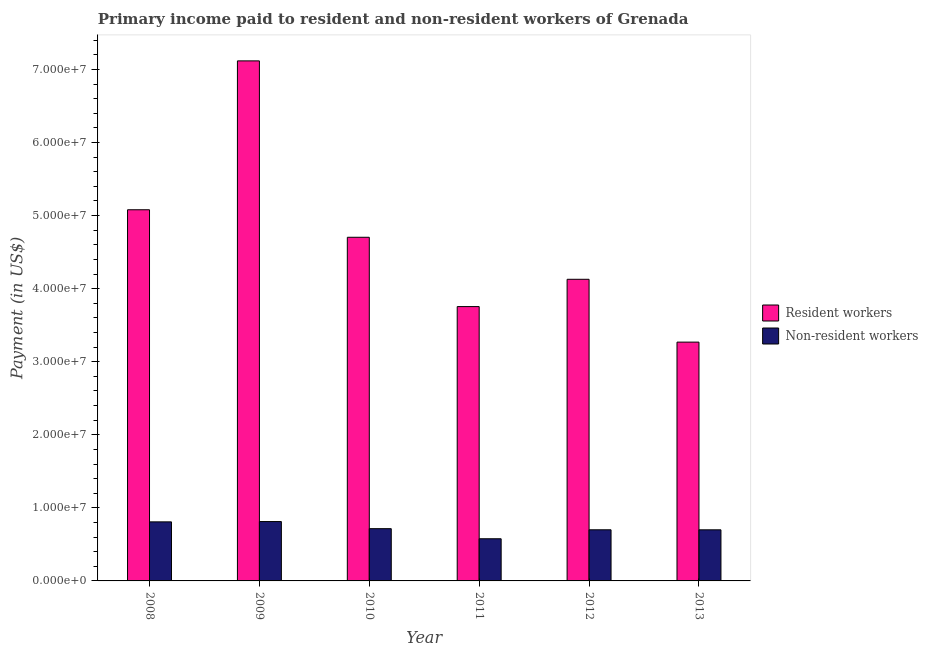Are the number of bars per tick equal to the number of legend labels?
Offer a very short reply. Yes. Are the number of bars on each tick of the X-axis equal?
Your answer should be very brief. Yes. How many bars are there on the 6th tick from the left?
Make the answer very short. 2. How many bars are there on the 1st tick from the right?
Your answer should be very brief. 2. What is the label of the 2nd group of bars from the left?
Ensure brevity in your answer.  2009. In how many cases, is the number of bars for a given year not equal to the number of legend labels?
Make the answer very short. 0. What is the payment made to non-resident workers in 2010?
Your answer should be very brief. 7.15e+06. Across all years, what is the maximum payment made to resident workers?
Give a very brief answer. 7.12e+07. Across all years, what is the minimum payment made to resident workers?
Your response must be concise. 3.27e+07. In which year was the payment made to non-resident workers maximum?
Provide a succinct answer. 2009. In which year was the payment made to resident workers minimum?
Provide a succinct answer. 2013. What is the total payment made to resident workers in the graph?
Offer a very short reply. 2.80e+08. What is the difference between the payment made to non-resident workers in 2012 and that in 2013?
Ensure brevity in your answer.  4373.7. What is the difference between the payment made to resident workers in 2012 and the payment made to non-resident workers in 2010?
Provide a short and direct response. -5.75e+06. What is the average payment made to resident workers per year?
Provide a succinct answer. 4.67e+07. In how many years, is the payment made to non-resident workers greater than 56000000 US$?
Offer a terse response. 0. What is the ratio of the payment made to resident workers in 2008 to that in 2010?
Your answer should be very brief. 1.08. Is the difference between the payment made to non-resident workers in 2011 and 2012 greater than the difference between the payment made to resident workers in 2011 and 2012?
Your response must be concise. No. What is the difference between the highest and the second highest payment made to resident workers?
Your answer should be very brief. 2.04e+07. What is the difference between the highest and the lowest payment made to resident workers?
Your answer should be very brief. 3.85e+07. In how many years, is the payment made to resident workers greater than the average payment made to resident workers taken over all years?
Offer a terse response. 3. What does the 1st bar from the left in 2009 represents?
Offer a terse response. Resident workers. What does the 2nd bar from the right in 2011 represents?
Offer a very short reply. Resident workers. How many years are there in the graph?
Make the answer very short. 6. Are the values on the major ticks of Y-axis written in scientific E-notation?
Keep it short and to the point. Yes. Does the graph contain grids?
Make the answer very short. No. Where does the legend appear in the graph?
Offer a very short reply. Center right. How many legend labels are there?
Offer a very short reply. 2. How are the legend labels stacked?
Your response must be concise. Vertical. What is the title of the graph?
Offer a very short reply. Primary income paid to resident and non-resident workers of Grenada. What is the label or title of the Y-axis?
Give a very brief answer. Payment (in US$). What is the Payment (in US$) in Resident workers in 2008?
Your response must be concise. 5.08e+07. What is the Payment (in US$) in Non-resident workers in 2008?
Provide a short and direct response. 8.08e+06. What is the Payment (in US$) of Resident workers in 2009?
Your response must be concise. 7.12e+07. What is the Payment (in US$) of Non-resident workers in 2009?
Offer a very short reply. 8.12e+06. What is the Payment (in US$) in Resident workers in 2010?
Your answer should be compact. 4.70e+07. What is the Payment (in US$) of Non-resident workers in 2010?
Ensure brevity in your answer.  7.15e+06. What is the Payment (in US$) of Resident workers in 2011?
Your response must be concise. 3.75e+07. What is the Payment (in US$) of Non-resident workers in 2011?
Provide a short and direct response. 5.77e+06. What is the Payment (in US$) in Resident workers in 2012?
Your answer should be compact. 4.13e+07. What is the Payment (in US$) in Non-resident workers in 2012?
Provide a short and direct response. 7.00e+06. What is the Payment (in US$) in Resident workers in 2013?
Make the answer very short. 3.27e+07. What is the Payment (in US$) of Non-resident workers in 2013?
Your answer should be compact. 6.99e+06. Across all years, what is the maximum Payment (in US$) in Resident workers?
Offer a terse response. 7.12e+07. Across all years, what is the maximum Payment (in US$) in Non-resident workers?
Give a very brief answer. 8.12e+06. Across all years, what is the minimum Payment (in US$) in Resident workers?
Ensure brevity in your answer.  3.27e+07. Across all years, what is the minimum Payment (in US$) of Non-resident workers?
Keep it short and to the point. 5.77e+06. What is the total Payment (in US$) of Resident workers in the graph?
Offer a very short reply. 2.80e+08. What is the total Payment (in US$) of Non-resident workers in the graph?
Your answer should be very brief. 4.31e+07. What is the difference between the Payment (in US$) in Resident workers in 2008 and that in 2009?
Ensure brevity in your answer.  -2.04e+07. What is the difference between the Payment (in US$) in Non-resident workers in 2008 and that in 2009?
Your answer should be very brief. -4.16e+04. What is the difference between the Payment (in US$) of Resident workers in 2008 and that in 2010?
Ensure brevity in your answer.  3.77e+06. What is the difference between the Payment (in US$) of Non-resident workers in 2008 and that in 2010?
Your response must be concise. 9.31e+05. What is the difference between the Payment (in US$) in Resident workers in 2008 and that in 2011?
Offer a terse response. 1.33e+07. What is the difference between the Payment (in US$) of Non-resident workers in 2008 and that in 2011?
Provide a succinct answer. 2.31e+06. What is the difference between the Payment (in US$) in Resident workers in 2008 and that in 2012?
Your answer should be very brief. 9.51e+06. What is the difference between the Payment (in US$) in Non-resident workers in 2008 and that in 2012?
Offer a terse response. 1.09e+06. What is the difference between the Payment (in US$) in Resident workers in 2008 and that in 2013?
Keep it short and to the point. 1.81e+07. What is the difference between the Payment (in US$) of Non-resident workers in 2008 and that in 2013?
Make the answer very short. 1.09e+06. What is the difference between the Payment (in US$) of Resident workers in 2009 and that in 2010?
Make the answer very short. 2.41e+07. What is the difference between the Payment (in US$) in Non-resident workers in 2009 and that in 2010?
Offer a terse response. 9.73e+05. What is the difference between the Payment (in US$) in Resident workers in 2009 and that in 2011?
Give a very brief answer. 3.36e+07. What is the difference between the Payment (in US$) of Non-resident workers in 2009 and that in 2011?
Offer a terse response. 2.35e+06. What is the difference between the Payment (in US$) of Resident workers in 2009 and that in 2012?
Provide a short and direct response. 2.99e+07. What is the difference between the Payment (in US$) of Non-resident workers in 2009 and that in 2012?
Offer a terse response. 1.13e+06. What is the difference between the Payment (in US$) of Resident workers in 2009 and that in 2013?
Offer a very short reply. 3.85e+07. What is the difference between the Payment (in US$) in Non-resident workers in 2009 and that in 2013?
Provide a short and direct response. 1.13e+06. What is the difference between the Payment (in US$) in Resident workers in 2010 and that in 2011?
Offer a very short reply. 9.49e+06. What is the difference between the Payment (in US$) of Non-resident workers in 2010 and that in 2011?
Ensure brevity in your answer.  1.38e+06. What is the difference between the Payment (in US$) of Resident workers in 2010 and that in 2012?
Provide a succinct answer. 5.75e+06. What is the difference between the Payment (in US$) of Non-resident workers in 2010 and that in 2012?
Give a very brief answer. 1.54e+05. What is the difference between the Payment (in US$) in Resident workers in 2010 and that in 2013?
Your answer should be very brief. 1.43e+07. What is the difference between the Payment (in US$) of Non-resident workers in 2010 and that in 2013?
Provide a succinct answer. 1.59e+05. What is the difference between the Payment (in US$) of Resident workers in 2011 and that in 2012?
Provide a short and direct response. -3.74e+06. What is the difference between the Payment (in US$) of Non-resident workers in 2011 and that in 2012?
Your answer should be compact. -1.23e+06. What is the difference between the Payment (in US$) in Resident workers in 2011 and that in 2013?
Provide a short and direct response. 4.86e+06. What is the difference between the Payment (in US$) of Non-resident workers in 2011 and that in 2013?
Give a very brief answer. -1.22e+06. What is the difference between the Payment (in US$) of Resident workers in 2012 and that in 2013?
Your answer should be compact. 8.60e+06. What is the difference between the Payment (in US$) of Non-resident workers in 2012 and that in 2013?
Ensure brevity in your answer.  4373.7. What is the difference between the Payment (in US$) of Resident workers in 2008 and the Payment (in US$) of Non-resident workers in 2009?
Your response must be concise. 4.27e+07. What is the difference between the Payment (in US$) in Resident workers in 2008 and the Payment (in US$) in Non-resident workers in 2010?
Offer a very short reply. 4.36e+07. What is the difference between the Payment (in US$) in Resident workers in 2008 and the Payment (in US$) in Non-resident workers in 2011?
Your answer should be very brief. 4.50e+07. What is the difference between the Payment (in US$) in Resident workers in 2008 and the Payment (in US$) in Non-resident workers in 2012?
Your answer should be very brief. 4.38e+07. What is the difference between the Payment (in US$) of Resident workers in 2008 and the Payment (in US$) of Non-resident workers in 2013?
Ensure brevity in your answer.  4.38e+07. What is the difference between the Payment (in US$) of Resident workers in 2009 and the Payment (in US$) of Non-resident workers in 2010?
Ensure brevity in your answer.  6.40e+07. What is the difference between the Payment (in US$) in Resident workers in 2009 and the Payment (in US$) in Non-resident workers in 2011?
Ensure brevity in your answer.  6.54e+07. What is the difference between the Payment (in US$) in Resident workers in 2009 and the Payment (in US$) in Non-resident workers in 2012?
Your answer should be very brief. 6.42e+07. What is the difference between the Payment (in US$) in Resident workers in 2009 and the Payment (in US$) in Non-resident workers in 2013?
Your answer should be compact. 6.42e+07. What is the difference between the Payment (in US$) of Resident workers in 2010 and the Payment (in US$) of Non-resident workers in 2011?
Make the answer very short. 4.13e+07. What is the difference between the Payment (in US$) in Resident workers in 2010 and the Payment (in US$) in Non-resident workers in 2012?
Provide a succinct answer. 4.00e+07. What is the difference between the Payment (in US$) of Resident workers in 2010 and the Payment (in US$) of Non-resident workers in 2013?
Your answer should be very brief. 4.00e+07. What is the difference between the Payment (in US$) in Resident workers in 2011 and the Payment (in US$) in Non-resident workers in 2012?
Ensure brevity in your answer.  3.05e+07. What is the difference between the Payment (in US$) of Resident workers in 2011 and the Payment (in US$) of Non-resident workers in 2013?
Your response must be concise. 3.06e+07. What is the difference between the Payment (in US$) of Resident workers in 2012 and the Payment (in US$) of Non-resident workers in 2013?
Your response must be concise. 3.43e+07. What is the average Payment (in US$) in Resident workers per year?
Give a very brief answer. 4.67e+07. What is the average Payment (in US$) of Non-resident workers per year?
Make the answer very short. 7.19e+06. In the year 2008, what is the difference between the Payment (in US$) of Resident workers and Payment (in US$) of Non-resident workers?
Your answer should be very brief. 4.27e+07. In the year 2009, what is the difference between the Payment (in US$) of Resident workers and Payment (in US$) of Non-resident workers?
Provide a succinct answer. 6.30e+07. In the year 2010, what is the difference between the Payment (in US$) of Resident workers and Payment (in US$) of Non-resident workers?
Ensure brevity in your answer.  3.99e+07. In the year 2011, what is the difference between the Payment (in US$) of Resident workers and Payment (in US$) of Non-resident workers?
Provide a short and direct response. 3.18e+07. In the year 2012, what is the difference between the Payment (in US$) of Resident workers and Payment (in US$) of Non-resident workers?
Your response must be concise. 3.43e+07. In the year 2013, what is the difference between the Payment (in US$) in Resident workers and Payment (in US$) in Non-resident workers?
Give a very brief answer. 2.57e+07. What is the ratio of the Payment (in US$) in Resident workers in 2008 to that in 2009?
Offer a terse response. 0.71. What is the ratio of the Payment (in US$) in Non-resident workers in 2008 to that in 2009?
Give a very brief answer. 0.99. What is the ratio of the Payment (in US$) of Resident workers in 2008 to that in 2010?
Make the answer very short. 1.08. What is the ratio of the Payment (in US$) in Non-resident workers in 2008 to that in 2010?
Your answer should be very brief. 1.13. What is the ratio of the Payment (in US$) in Resident workers in 2008 to that in 2011?
Offer a terse response. 1.35. What is the ratio of the Payment (in US$) in Non-resident workers in 2008 to that in 2011?
Your answer should be very brief. 1.4. What is the ratio of the Payment (in US$) of Resident workers in 2008 to that in 2012?
Your answer should be very brief. 1.23. What is the ratio of the Payment (in US$) of Non-resident workers in 2008 to that in 2012?
Give a very brief answer. 1.16. What is the ratio of the Payment (in US$) of Resident workers in 2008 to that in 2013?
Your response must be concise. 1.55. What is the ratio of the Payment (in US$) in Non-resident workers in 2008 to that in 2013?
Your answer should be very brief. 1.16. What is the ratio of the Payment (in US$) in Resident workers in 2009 to that in 2010?
Offer a terse response. 1.51. What is the ratio of the Payment (in US$) of Non-resident workers in 2009 to that in 2010?
Your answer should be very brief. 1.14. What is the ratio of the Payment (in US$) of Resident workers in 2009 to that in 2011?
Give a very brief answer. 1.9. What is the ratio of the Payment (in US$) in Non-resident workers in 2009 to that in 2011?
Provide a succinct answer. 1.41. What is the ratio of the Payment (in US$) of Resident workers in 2009 to that in 2012?
Ensure brevity in your answer.  1.72. What is the ratio of the Payment (in US$) of Non-resident workers in 2009 to that in 2012?
Offer a very short reply. 1.16. What is the ratio of the Payment (in US$) of Resident workers in 2009 to that in 2013?
Your answer should be very brief. 2.18. What is the ratio of the Payment (in US$) in Non-resident workers in 2009 to that in 2013?
Your response must be concise. 1.16. What is the ratio of the Payment (in US$) of Resident workers in 2010 to that in 2011?
Keep it short and to the point. 1.25. What is the ratio of the Payment (in US$) in Non-resident workers in 2010 to that in 2011?
Keep it short and to the point. 1.24. What is the ratio of the Payment (in US$) of Resident workers in 2010 to that in 2012?
Your response must be concise. 1.14. What is the ratio of the Payment (in US$) of Non-resident workers in 2010 to that in 2012?
Give a very brief answer. 1.02. What is the ratio of the Payment (in US$) of Resident workers in 2010 to that in 2013?
Offer a very short reply. 1.44. What is the ratio of the Payment (in US$) in Non-resident workers in 2010 to that in 2013?
Give a very brief answer. 1.02. What is the ratio of the Payment (in US$) of Resident workers in 2011 to that in 2012?
Offer a very short reply. 0.91. What is the ratio of the Payment (in US$) of Non-resident workers in 2011 to that in 2012?
Provide a succinct answer. 0.82. What is the ratio of the Payment (in US$) in Resident workers in 2011 to that in 2013?
Your answer should be compact. 1.15. What is the ratio of the Payment (in US$) in Non-resident workers in 2011 to that in 2013?
Your answer should be very brief. 0.83. What is the ratio of the Payment (in US$) of Resident workers in 2012 to that in 2013?
Make the answer very short. 1.26. What is the difference between the highest and the second highest Payment (in US$) in Resident workers?
Provide a short and direct response. 2.04e+07. What is the difference between the highest and the second highest Payment (in US$) in Non-resident workers?
Offer a very short reply. 4.16e+04. What is the difference between the highest and the lowest Payment (in US$) in Resident workers?
Give a very brief answer. 3.85e+07. What is the difference between the highest and the lowest Payment (in US$) in Non-resident workers?
Make the answer very short. 2.35e+06. 